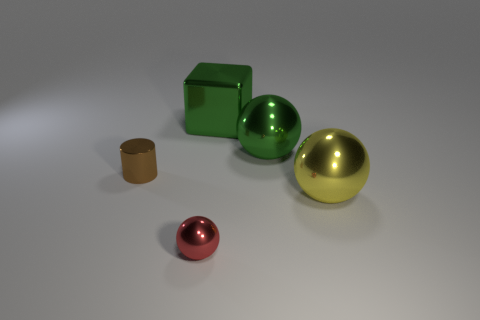Add 1 gray matte balls. How many objects exist? 6 Subtract all balls. How many objects are left? 2 Add 2 red objects. How many red objects exist? 3 Subtract 0 cyan blocks. How many objects are left? 5 Subtract all yellow metallic objects. Subtract all yellow things. How many objects are left? 3 Add 5 green blocks. How many green blocks are left? 6 